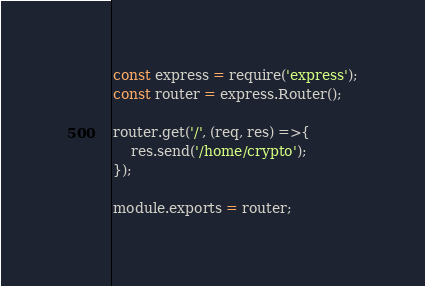<code> <loc_0><loc_0><loc_500><loc_500><_JavaScript_>const express = require('express');
const router = express.Router();

router.get('/', (req, res) =>{
    res.send('/home/crypto');
});

module.exports = router;</code> 